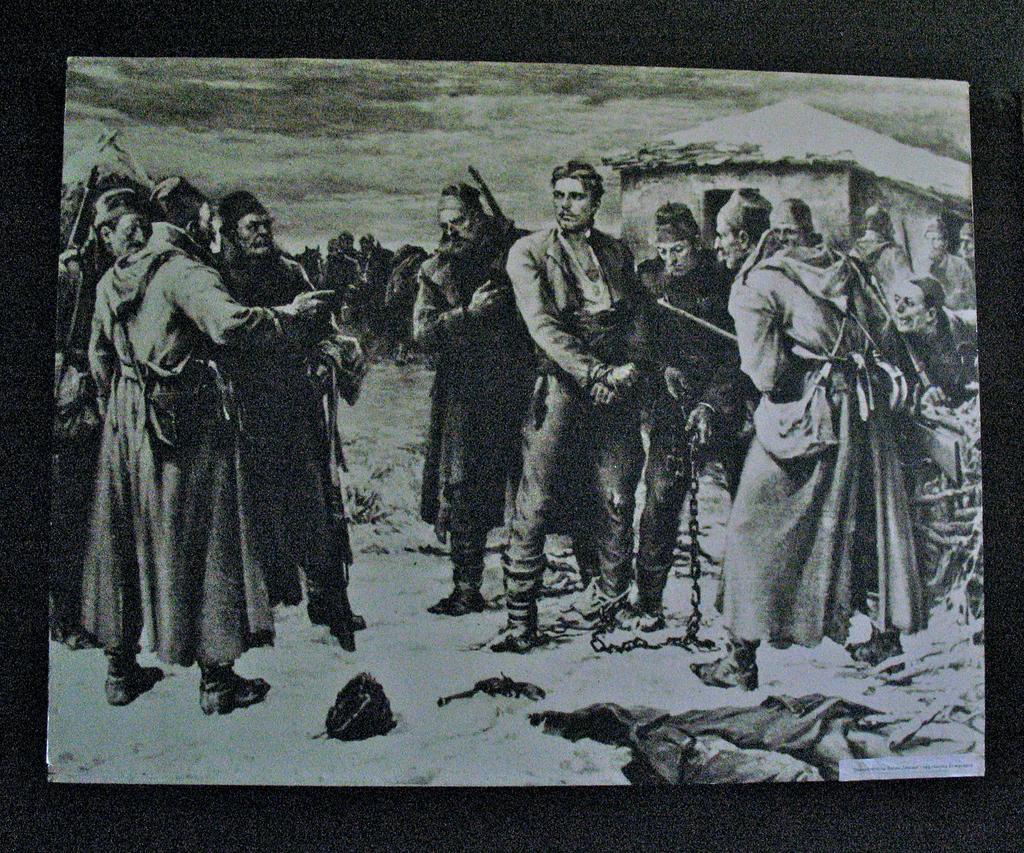Please provide a concise description of this image. This is a black and picture, in this image we can see a photograph, in the photograph there are few people, a house and some other objects, in the background we can see the sky with clouds. 